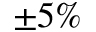Convert formula to latex. <formula><loc_0><loc_0><loc_500><loc_500>\pm 5 \%</formula> 